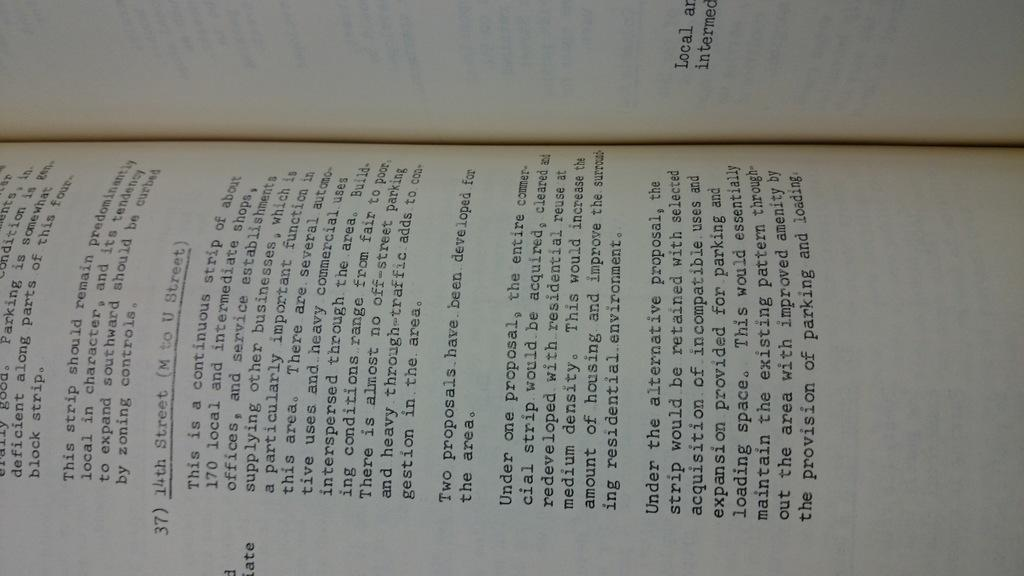<image>
Relay a brief, clear account of the picture shown. An open book curved in a way common to open books with text. 